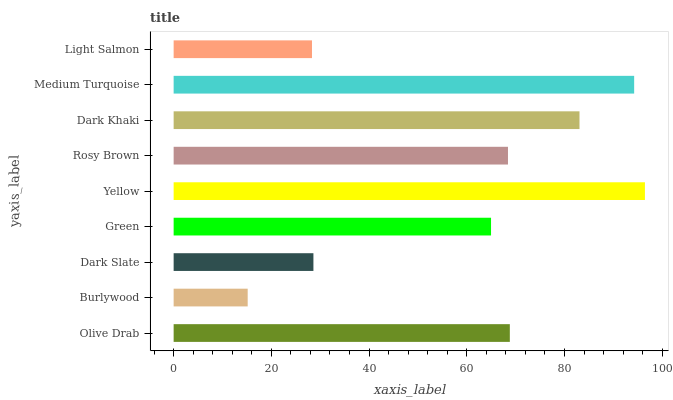Is Burlywood the minimum?
Answer yes or no. Yes. Is Yellow the maximum?
Answer yes or no. Yes. Is Dark Slate the minimum?
Answer yes or no. No. Is Dark Slate the maximum?
Answer yes or no. No. Is Dark Slate greater than Burlywood?
Answer yes or no. Yes. Is Burlywood less than Dark Slate?
Answer yes or no. Yes. Is Burlywood greater than Dark Slate?
Answer yes or no. No. Is Dark Slate less than Burlywood?
Answer yes or no. No. Is Rosy Brown the high median?
Answer yes or no. Yes. Is Rosy Brown the low median?
Answer yes or no. Yes. Is Olive Drab the high median?
Answer yes or no. No. Is Medium Turquoise the low median?
Answer yes or no. No. 